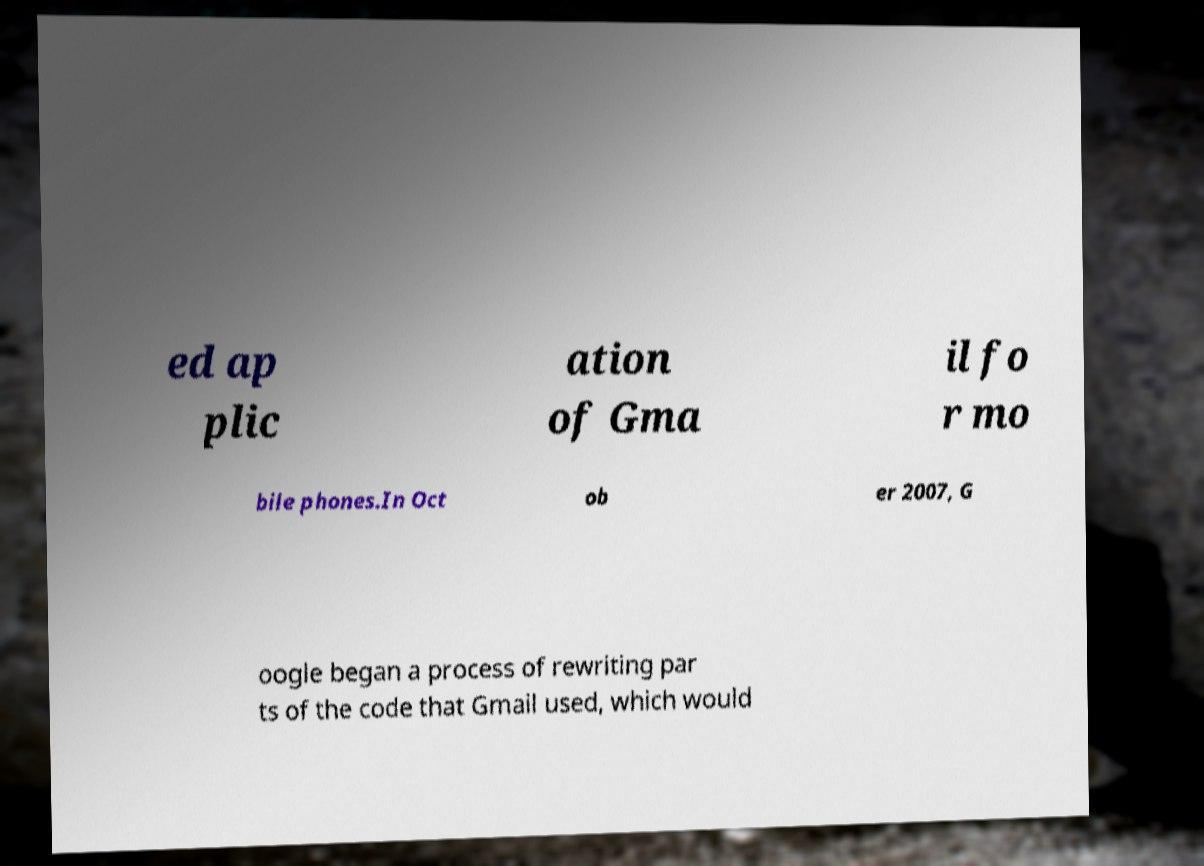What messages or text are displayed in this image? I need them in a readable, typed format. ed ap plic ation of Gma il fo r mo bile phones.In Oct ob er 2007, G oogle began a process of rewriting par ts of the code that Gmail used, which would 